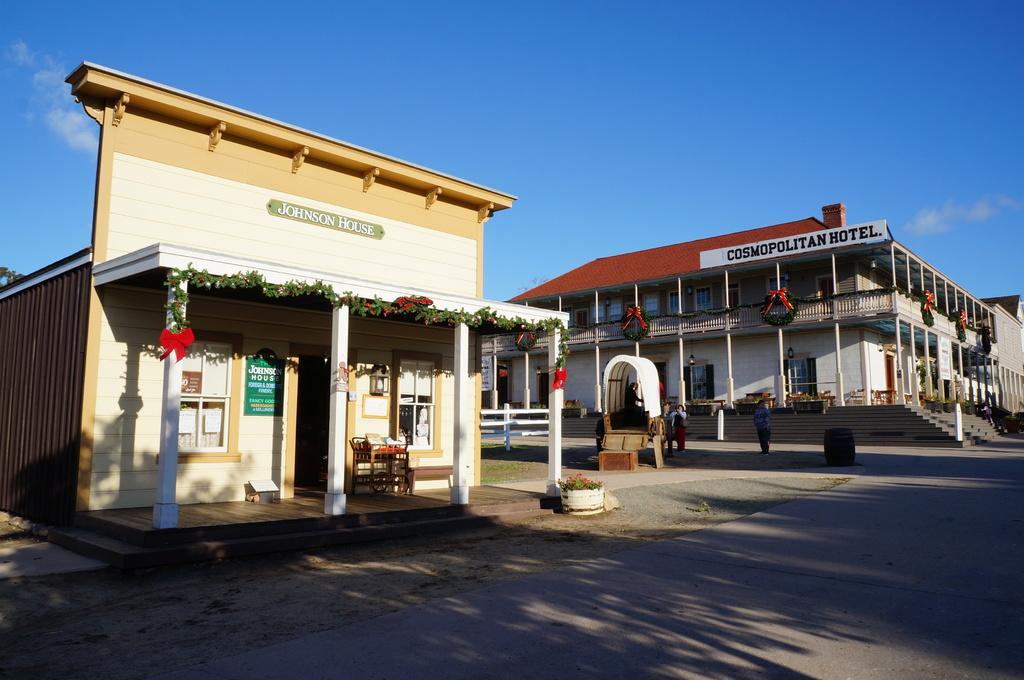Can you describe this image briefly? Here in this picture in the front we can see a store present on the ground over there and the store front is decorated with flowers over there and beside it we can see a hotel present and we can see it is also decorated in the front and we can see people walking on the road here and there and we can see clouds in the sky. 